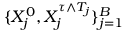<formula> <loc_0><loc_0><loc_500><loc_500>\{ X _ { j } ^ { 0 } , X _ { j } ^ { \tau \wedge T _ { j } } \} _ { j = 1 } ^ { B }</formula> 